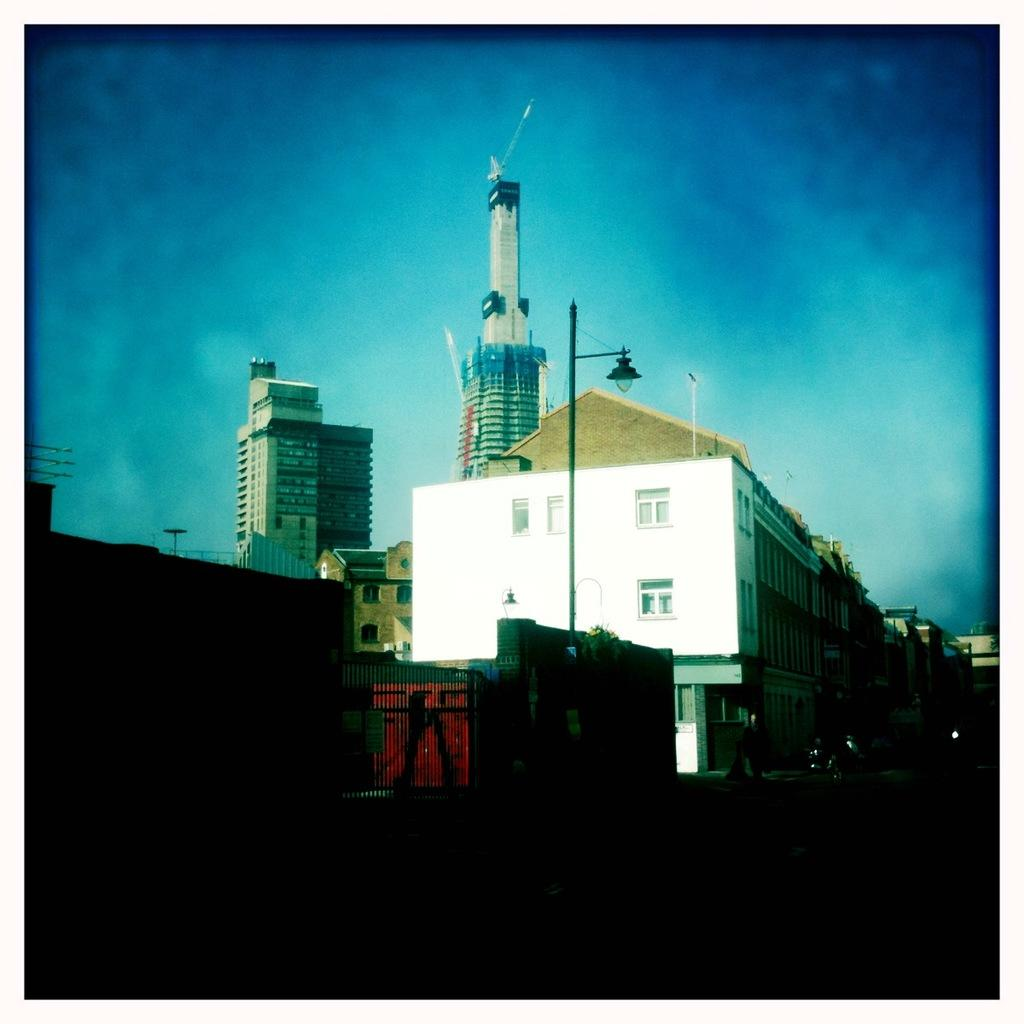What type of structures can be seen in the image? There are many buildings in the image. What feature do the buildings have in common? The buildings have windows. Can you describe any other objects or features in the image? There is a light pole in front of a building and a railing visible in the image. What type of bone can be seen sticking out of the building in the image? There is no bone visible in the image; it features buildings, a light pole, and a railing. 